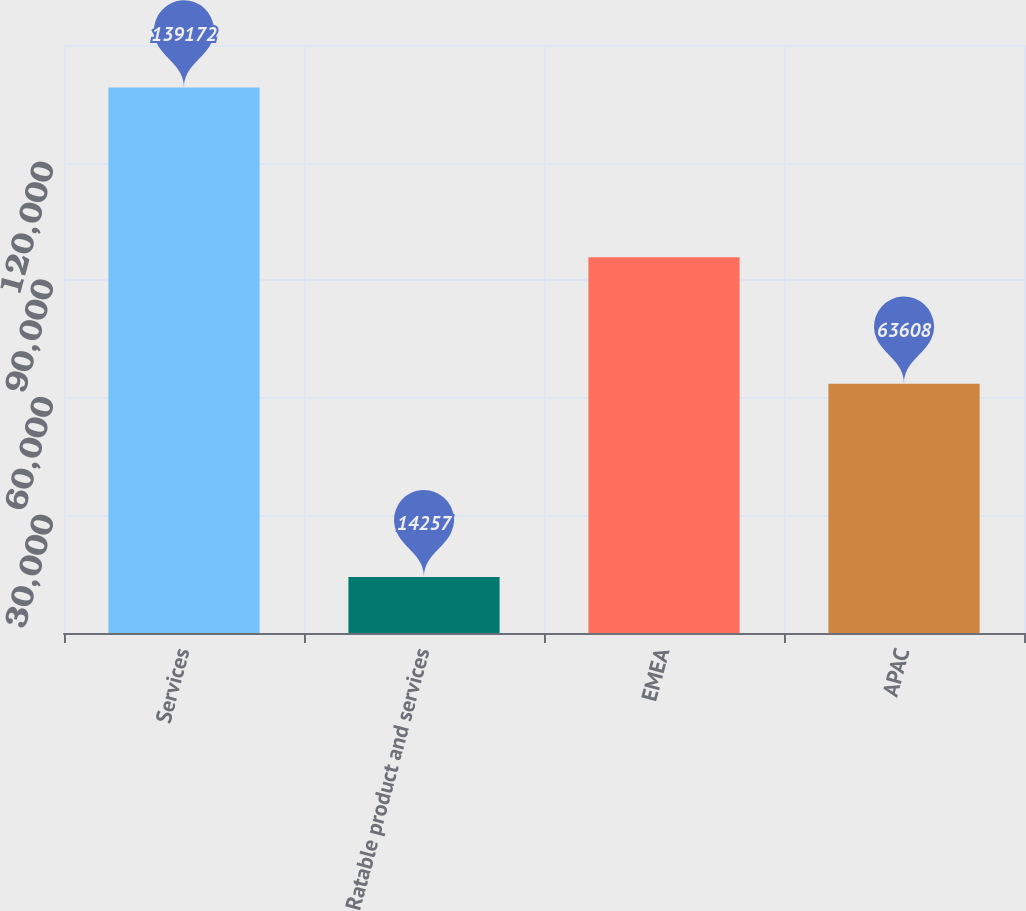Convert chart to OTSL. <chart><loc_0><loc_0><loc_500><loc_500><bar_chart><fcel>Services<fcel>Ratable product and services<fcel>EMEA<fcel>APAC<nl><fcel>139172<fcel>14257<fcel>95886<fcel>63608<nl></chart> 